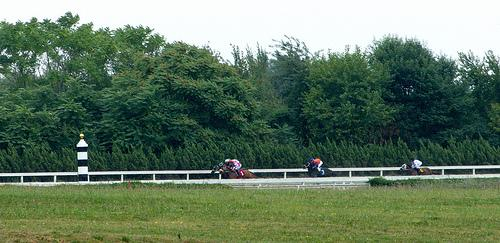What objects are near the race track and how many of them are in the image? Near the race track, there are trees, a green shrub, a grass field, a black and white post on the railings, and white railings, with at least one of each present in the image. Enumerate the observable colors of the jockeys' apparel and helmets. The observed colors include red and white outfits, a blue helmet worn by the rider in the middle, and white clothing on the rider on the far right. In the context of this image, what aspects of the weather can be observed? The image portrays cloudy weather, with the sky in the background showing cloud cover. Describe the objects related to the fence in the image. There are white railings, a black and white structure, and a gold ball on top of a stripe structure, all located along the edge of the race track. Provide a brief description of the landscape surrounding the race track. The landscape features green trees, a grass field, and a green hedgerow next to the race track, with white railings and fence also present in the area. What does the image suggest about the performance of the horses and their jockeys? The image implies that the horses are running fast and close to each other, and their jockeys are trying hard to win the race, thus providing a competitive atmosphere. What dominates the scene in the image and how are the main subjects interacting? The scene is dominated by a group of people riding race horses, competing against each other in a horse racing track, and trying hard to win by making their horses run fast. How many horses are present in the image and what are their respective positions? There are three horses present in the image: one on the left, one in the middle, and one on the right. What feelings or emotions can be inferred from the image? The image evokes feelings of excitement, competition, and determination as the riders are competing intensely in the horse race on a nice day. Is the horse rider in front wearing a blue helmet? No, it's not mentioned in the image. Is the horse rider in the back wearing a yellow outfit? The question implies that the horse rider in the back is wearing a yellow outfit, which is incorrect as there is no information about a rider wearing a yellow outfit. 